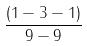<formula> <loc_0><loc_0><loc_500><loc_500>\frac { ( 1 - 3 - 1 ) } { 9 - 9 }</formula> 